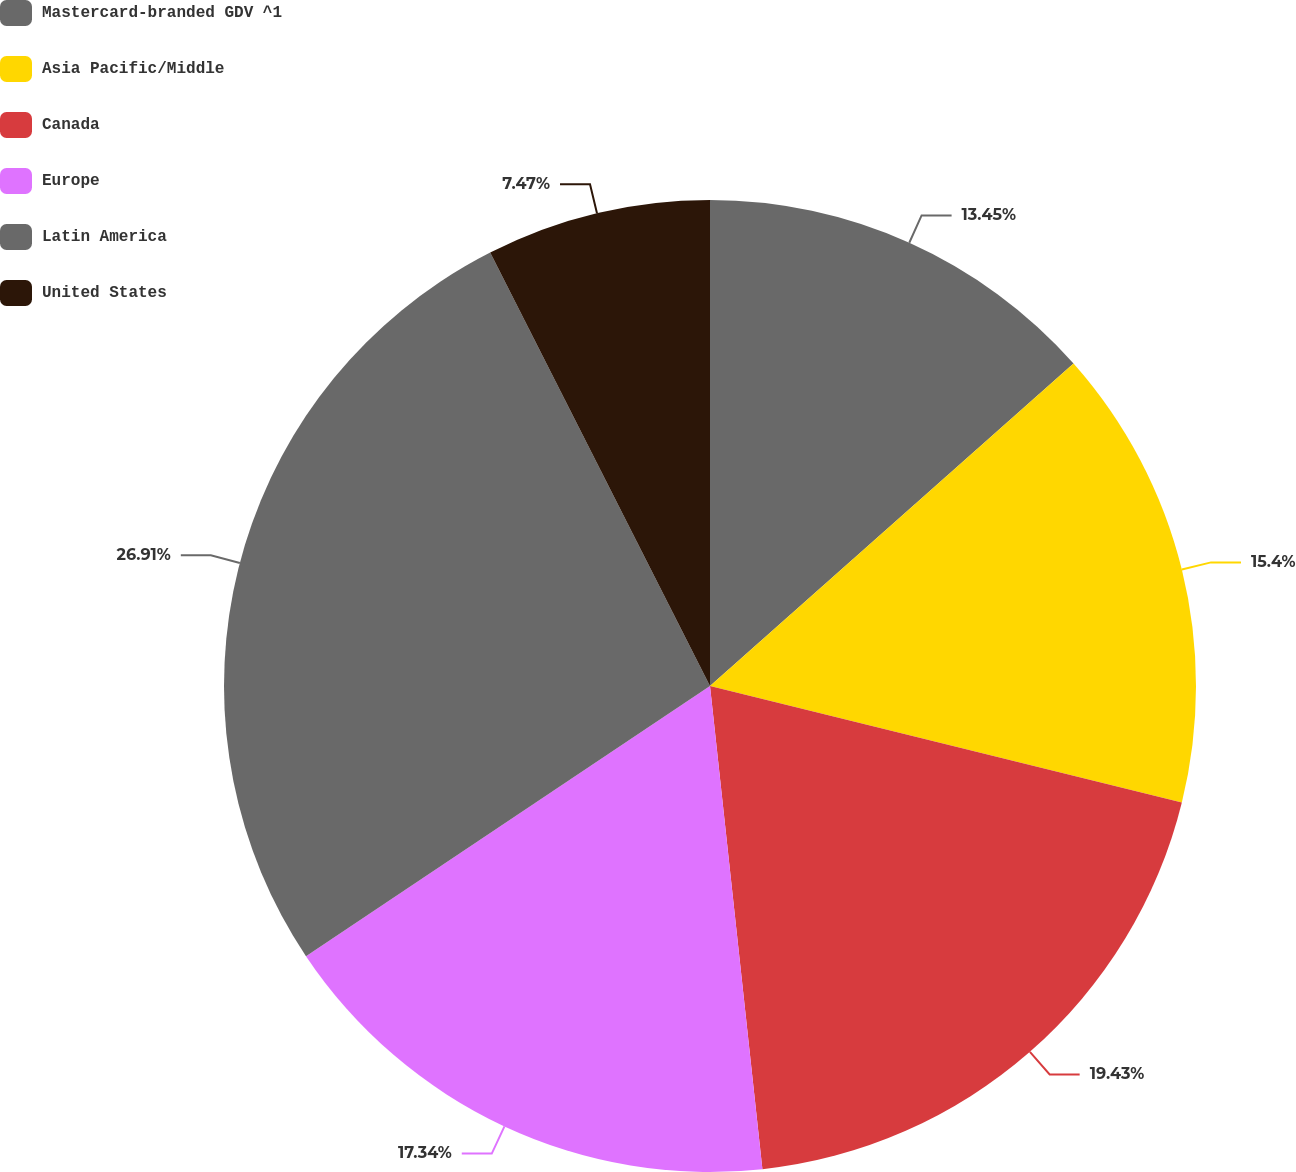<chart> <loc_0><loc_0><loc_500><loc_500><pie_chart><fcel>Mastercard-branded GDV ^1<fcel>Asia Pacific/Middle<fcel>Canada<fcel>Europe<fcel>Latin America<fcel>United States<nl><fcel>13.45%<fcel>15.4%<fcel>19.43%<fcel>17.34%<fcel>26.91%<fcel>7.47%<nl></chart> 